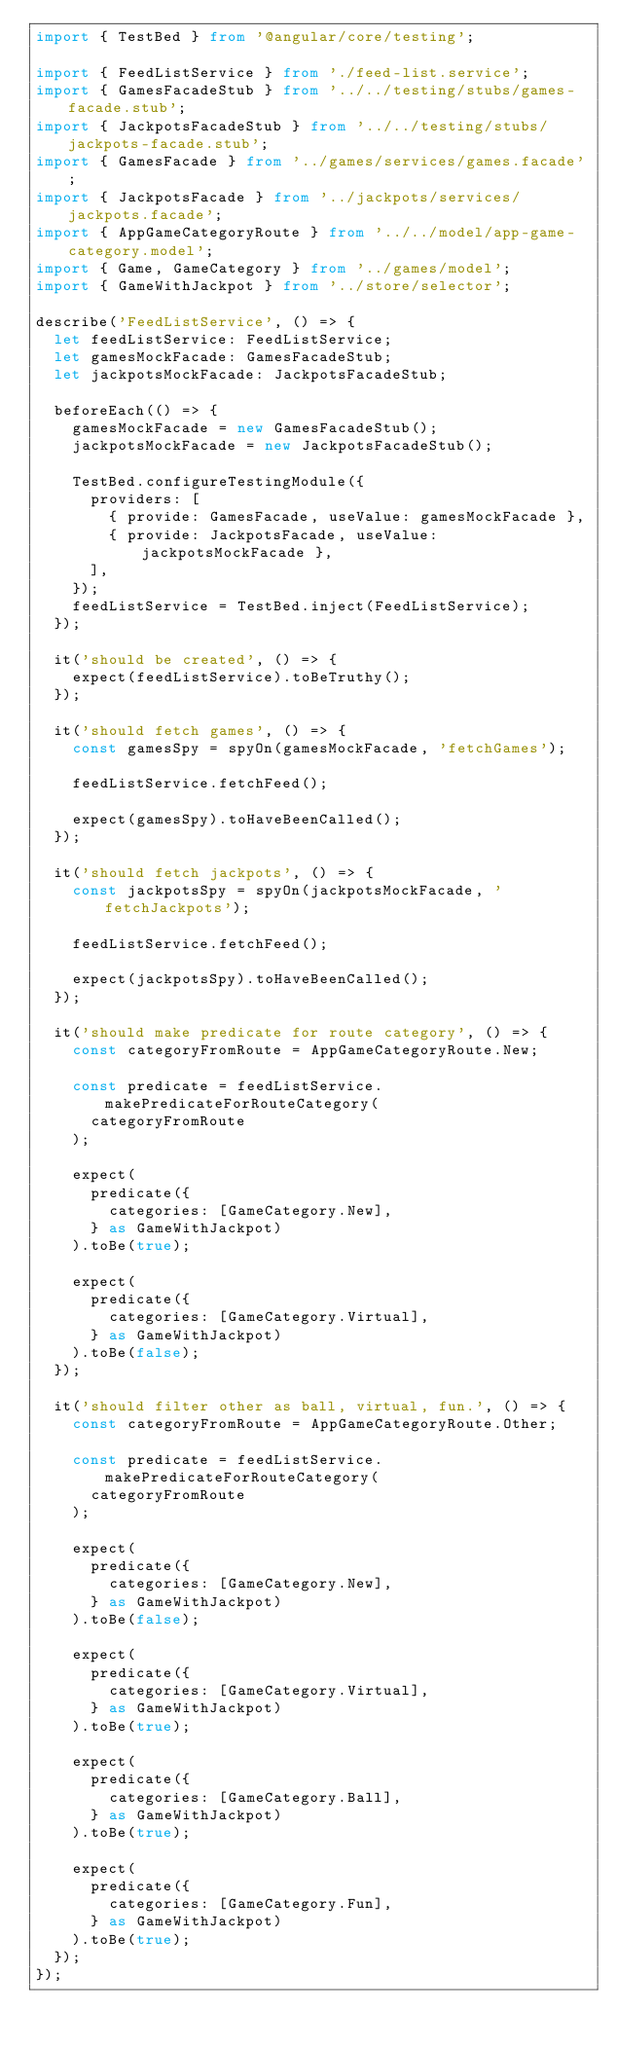<code> <loc_0><loc_0><loc_500><loc_500><_TypeScript_>import { TestBed } from '@angular/core/testing';

import { FeedListService } from './feed-list.service';
import { GamesFacadeStub } from '../../testing/stubs/games-facade.stub';
import { JackpotsFacadeStub } from '../../testing/stubs/jackpots-facade.stub';
import { GamesFacade } from '../games/services/games.facade';
import { JackpotsFacade } from '../jackpots/services/jackpots.facade';
import { AppGameCategoryRoute } from '../../model/app-game-category.model';
import { Game, GameCategory } from '../games/model';
import { GameWithJackpot } from '../store/selector';

describe('FeedListService', () => {
  let feedListService: FeedListService;
  let gamesMockFacade: GamesFacadeStub;
  let jackpotsMockFacade: JackpotsFacadeStub;

  beforeEach(() => {
    gamesMockFacade = new GamesFacadeStub();
    jackpotsMockFacade = new JackpotsFacadeStub();

    TestBed.configureTestingModule({
      providers: [
        { provide: GamesFacade, useValue: gamesMockFacade },
        { provide: JackpotsFacade, useValue: jackpotsMockFacade },
      ],
    });
    feedListService = TestBed.inject(FeedListService);
  });

  it('should be created', () => {
    expect(feedListService).toBeTruthy();
  });

  it('should fetch games', () => {
    const gamesSpy = spyOn(gamesMockFacade, 'fetchGames');

    feedListService.fetchFeed();

    expect(gamesSpy).toHaveBeenCalled();
  });

  it('should fetch jackpots', () => {
    const jackpotsSpy = spyOn(jackpotsMockFacade, 'fetchJackpots');

    feedListService.fetchFeed();

    expect(jackpotsSpy).toHaveBeenCalled();
  });

  it('should make predicate for route category', () => {
    const categoryFromRoute = AppGameCategoryRoute.New;

    const predicate = feedListService.makePredicateForRouteCategory(
      categoryFromRoute
    );

    expect(
      predicate({
        categories: [GameCategory.New],
      } as GameWithJackpot)
    ).toBe(true);

    expect(
      predicate({
        categories: [GameCategory.Virtual],
      } as GameWithJackpot)
    ).toBe(false);
  });

  it('should filter other as ball, virtual, fun.', () => {
    const categoryFromRoute = AppGameCategoryRoute.Other;

    const predicate = feedListService.makePredicateForRouteCategory(
      categoryFromRoute
    );

    expect(
      predicate({
        categories: [GameCategory.New],
      } as GameWithJackpot)
    ).toBe(false);

    expect(
      predicate({
        categories: [GameCategory.Virtual],
      } as GameWithJackpot)
    ).toBe(true);

    expect(
      predicate({
        categories: [GameCategory.Ball],
      } as GameWithJackpot)
    ).toBe(true);

    expect(
      predicate({
        categories: [GameCategory.Fun],
      } as GameWithJackpot)
    ).toBe(true);
  });
});
</code> 